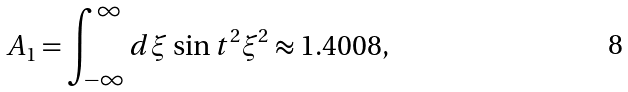<formula> <loc_0><loc_0><loc_500><loc_500>A _ { 1 } = \int _ { - \infty } ^ { \infty } d \xi \, \sin t ^ { 2 } \xi ^ { 2 } \approx 1 . 4 0 0 8 ,</formula> 